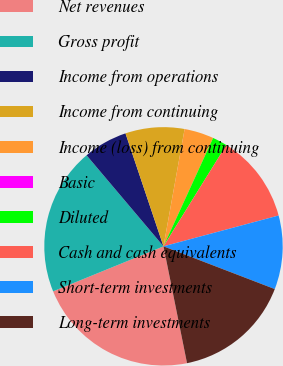Convert chart. <chart><loc_0><loc_0><loc_500><loc_500><pie_chart><fcel>Net revenues<fcel>Gross profit<fcel>Income from operations<fcel>Income from continuing<fcel>Income (loss) from continuing<fcel>Basic<fcel>Diluted<fcel>Cash and cash equivalents<fcel>Short-term investments<fcel>Long-term investments<nl><fcel>22.0%<fcel>20.0%<fcel>6.0%<fcel>8.0%<fcel>4.0%<fcel>0.0%<fcel>2.0%<fcel>12.0%<fcel>10.0%<fcel>16.0%<nl></chart> 